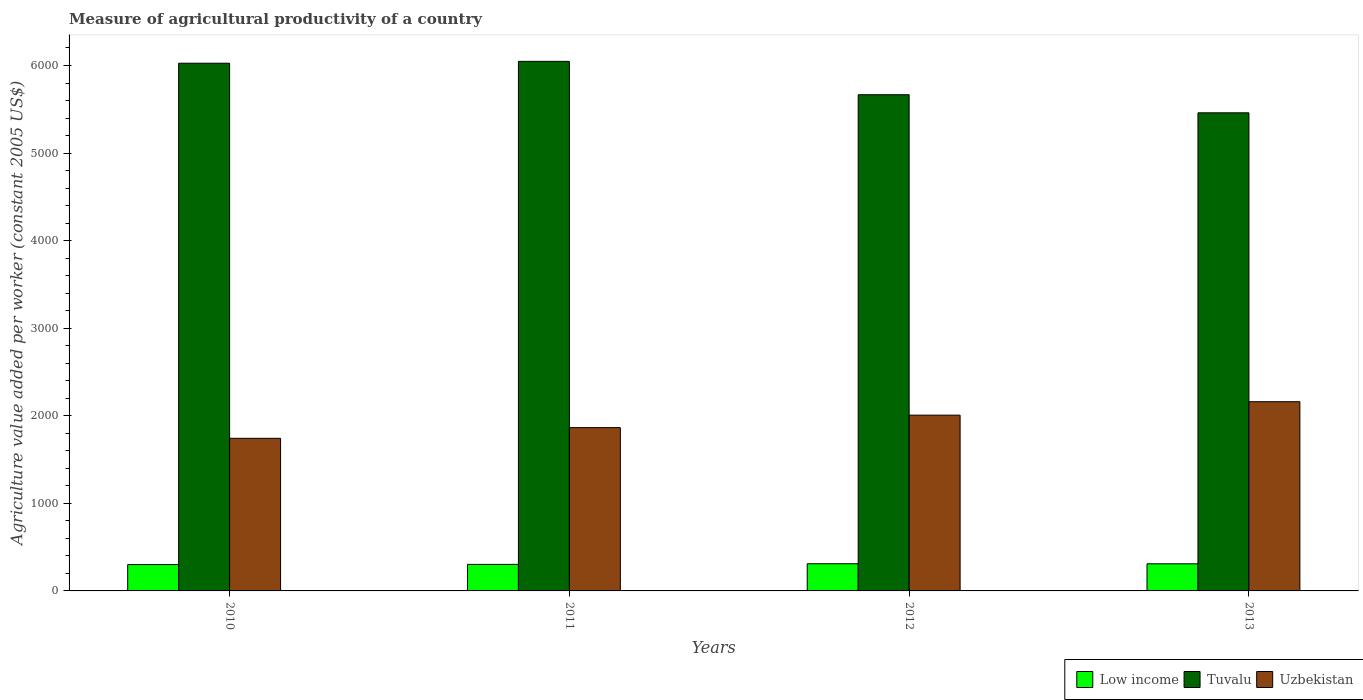How many different coloured bars are there?
Provide a short and direct response. 3. Are the number of bars per tick equal to the number of legend labels?
Provide a succinct answer. Yes. How many bars are there on the 3rd tick from the left?
Provide a short and direct response. 3. In how many cases, is the number of bars for a given year not equal to the number of legend labels?
Offer a very short reply. 0. What is the measure of agricultural productivity in Low income in 2012?
Offer a very short reply. 310.29. Across all years, what is the maximum measure of agricultural productivity in Tuvalu?
Provide a succinct answer. 6047.47. Across all years, what is the minimum measure of agricultural productivity in Uzbekistan?
Your answer should be compact. 1742.87. What is the total measure of agricultural productivity in Low income in the graph?
Give a very brief answer. 1223.9. What is the difference between the measure of agricultural productivity in Uzbekistan in 2011 and that in 2012?
Provide a short and direct response. -142.45. What is the difference between the measure of agricultural productivity in Tuvalu in 2011 and the measure of agricultural productivity in Low income in 2012?
Keep it short and to the point. 5737.18. What is the average measure of agricultural productivity in Low income per year?
Offer a very short reply. 305.97. In the year 2013, what is the difference between the measure of agricultural productivity in Uzbekistan and measure of agricultural productivity in Tuvalu?
Your answer should be very brief. -3299.08. In how many years, is the measure of agricultural productivity in Low income greater than 1600 US$?
Give a very brief answer. 0. What is the ratio of the measure of agricultural productivity in Uzbekistan in 2011 to that in 2012?
Your answer should be compact. 0.93. Is the difference between the measure of agricultural productivity in Uzbekistan in 2011 and 2012 greater than the difference between the measure of agricultural productivity in Tuvalu in 2011 and 2012?
Ensure brevity in your answer.  No. What is the difference between the highest and the second highest measure of agricultural productivity in Low income?
Keep it short and to the point. 0.69. What is the difference between the highest and the lowest measure of agricultural productivity in Tuvalu?
Your response must be concise. 587.72. Is the sum of the measure of agricultural productivity in Tuvalu in 2011 and 2013 greater than the maximum measure of agricultural productivity in Uzbekistan across all years?
Your response must be concise. Yes. What does the 2nd bar from the left in 2011 represents?
Ensure brevity in your answer.  Tuvalu. What does the 1st bar from the right in 2010 represents?
Your answer should be very brief. Uzbekistan. Is it the case that in every year, the sum of the measure of agricultural productivity in Tuvalu and measure of agricultural productivity in Uzbekistan is greater than the measure of agricultural productivity in Low income?
Make the answer very short. Yes. Are all the bars in the graph horizontal?
Your answer should be very brief. No. Are the values on the major ticks of Y-axis written in scientific E-notation?
Ensure brevity in your answer.  No. Where does the legend appear in the graph?
Keep it short and to the point. Bottom right. How many legend labels are there?
Keep it short and to the point. 3. How are the legend labels stacked?
Offer a terse response. Horizontal. What is the title of the graph?
Offer a terse response. Measure of agricultural productivity of a country. Does "Solomon Islands" appear as one of the legend labels in the graph?
Make the answer very short. No. What is the label or title of the X-axis?
Offer a very short reply. Years. What is the label or title of the Y-axis?
Your answer should be compact. Agriculture value added per worker (constant 2005 US$). What is the Agriculture value added per worker (constant 2005 US$) of Low income in 2010?
Provide a succinct answer. 300.88. What is the Agriculture value added per worker (constant 2005 US$) of Tuvalu in 2010?
Your answer should be compact. 6026.09. What is the Agriculture value added per worker (constant 2005 US$) in Uzbekistan in 2010?
Give a very brief answer. 1742.87. What is the Agriculture value added per worker (constant 2005 US$) in Low income in 2011?
Ensure brevity in your answer.  303.13. What is the Agriculture value added per worker (constant 2005 US$) of Tuvalu in 2011?
Provide a short and direct response. 6047.47. What is the Agriculture value added per worker (constant 2005 US$) in Uzbekistan in 2011?
Provide a succinct answer. 1864.79. What is the Agriculture value added per worker (constant 2005 US$) of Low income in 2012?
Your response must be concise. 310.29. What is the Agriculture value added per worker (constant 2005 US$) of Tuvalu in 2012?
Offer a very short reply. 5666.4. What is the Agriculture value added per worker (constant 2005 US$) in Uzbekistan in 2012?
Offer a very short reply. 2007.24. What is the Agriculture value added per worker (constant 2005 US$) in Low income in 2013?
Ensure brevity in your answer.  309.6. What is the Agriculture value added per worker (constant 2005 US$) of Tuvalu in 2013?
Provide a short and direct response. 5459.75. What is the Agriculture value added per worker (constant 2005 US$) of Uzbekistan in 2013?
Provide a short and direct response. 2160.67. Across all years, what is the maximum Agriculture value added per worker (constant 2005 US$) of Low income?
Your response must be concise. 310.29. Across all years, what is the maximum Agriculture value added per worker (constant 2005 US$) in Tuvalu?
Ensure brevity in your answer.  6047.47. Across all years, what is the maximum Agriculture value added per worker (constant 2005 US$) in Uzbekistan?
Provide a short and direct response. 2160.67. Across all years, what is the minimum Agriculture value added per worker (constant 2005 US$) in Low income?
Ensure brevity in your answer.  300.88. Across all years, what is the minimum Agriculture value added per worker (constant 2005 US$) of Tuvalu?
Ensure brevity in your answer.  5459.75. Across all years, what is the minimum Agriculture value added per worker (constant 2005 US$) in Uzbekistan?
Offer a terse response. 1742.87. What is the total Agriculture value added per worker (constant 2005 US$) in Low income in the graph?
Provide a short and direct response. 1223.9. What is the total Agriculture value added per worker (constant 2005 US$) in Tuvalu in the graph?
Make the answer very short. 2.32e+04. What is the total Agriculture value added per worker (constant 2005 US$) of Uzbekistan in the graph?
Offer a very short reply. 7775.57. What is the difference between the Agriculture value added per worker (constant 2005 US$) of Low income in 2010 and that in 2011?
Provide a succinct answer. -2.26. What is the difference between the Agriculture value added per worker (constant 2005 US$) of Tuvalu in 2010 and that in 2011?
Give a very brief answer. -21.38. What is the difference between the Agriculture value added per worker (constant 2005 US$) in Uzbekistan in 2010 and that in 2011?
Offer a terse response. -121.92. What is the difference between the Agriculture value added per worker (constant 2005 US$) of Low income in 2010 and that in 2012?
Keep it short and to the point. -9.41. What is the difference between the Agriculture value added per worker (constant 2005 US$) in Tuvalu in 2010 and that in 2012?
Your answer should be compact. 359.69. What is the difference between the Agriculture value added per worker (constant 2005 US$) of Uzbekistan in 2010 and that in 2012?
Your answer should be compact. -264.38. What is the difference between the Agriculture value added per worker (constant 2005 US$) in Low income in 2010 and that in 2013?
Offer a very short reply. -8.72. What is the difference between the Agriculture value added per worker (constant 2005 US$) of Tuvalu in 2010 and that in 2013?
Ensure brevity in your answer.  566.33. What is the difference between the Agriculture value added per worker (constant 2005 US$) in Uzbekistan in 2010 and that in 2013?
Offer a very short reply. -417.8. What is the difference between the Agriculture value added per worker (constant 2005 US$) of Low income in 2011 and that in 2012?
Keep it short and to the point. -7.16. What is the difference between the Agriculture value added per worker (constant 2005 US$) of Tuvalu in 2011 and that in 2012?
Keep it short and to the point. 381.07. What is the difference between the Agriculture value added per worker (constant 2005 US$) in Uzbekistan in 2011 and that in 2012?
Your response must be concise. -142.45. What is the difference between the Agriculture value added per worker (constant 2005 US$) of Low income in 2011 and that in 2013?
Your answer should be very brief. -6.46. What is the difference between the Agriculture value added per worker (constant 2005 US$) of Tuvalu in 2011 and that in 2013?
Keep it short and to the point. 587.72. What is the difference between the Agriculture value added per worker (constant 2005 US$) in Uzbekistan in 2011 and that in 2013?
Make the answer very short. -295.88. What is the difference between the Agriculture value added per worker (constant 2005 US$) of Low income in 2012 and that in 2013?
Make the answer very short. 0.69. What is the difference between the Agriculture value added per worker (constant 2005 US$) of Tuvalu in 2012 and that in 2013?
Make the answer very short. 206.65. What is the difference between the Agriculture value added per worker (constant 2005 US$) of Uzbekistan in 2012 and that in 2013?
Keep it short and to the point. -153.43. What is the difference between the Agriculture value added per worker (constant 2005 US$) in Low income in 2010 and the Agriculture value added per worker (constant 2005 US$) in Tuvalu in 2011?
Ensure brevity in your answer.  -5746.59. What is the difference between the Agriculture value added per worker (constant 2005 US$) in Low income in 2010 and the Agriculture value added per worker (constant 2005 US$) in Uzbekistan in 2011?
Your answer should be compact. -1563.91. What is the difference between the Agriculture value added per worker (constant 2005 US$) in Tuvalu in 2010 and the Agriculture value added per worker (constant 2005 US$) in Uzbekistan in 2011?
Ensure brevity in your answer.  4161.3. What is the difference between the Agriculture value added per worker (constant 2005 US$) in Low income in 2010 and the Agriculture value added per worker (constant 2005 US$) in Tuvalu in 2012?
Make the answer very short. -5365.52. What is the difference between the Agriculture value added per worker (constant 2005 US$) of Low income in 2010 and the Agriculture value added per worker (constant 2005 US$) of Uzbekistan in 2012?
Your answer should be compact. -1706.36. What is the difference between the Agriculture value added per worker (constant 2005 US$) in Tuvalu in 2010 and the Agriculture value added per worker (constant 2005 US$) in Uzbekistan in 2012?
Make the answer very short. 4018.85. What is the difference between the Agriculture value added per worker (constant 2005 US$) in Low income in 2010 and the Agriculture value added per worker (constant 2005 US$) in Tuvalu in 2013?
Your answer should be very brief. -5158.88. What is the difference between the Agriculture value added per worker (constant 2005 US$) in Low income in 2010 and the Agriculture value added per worker (constant 2005 US$) in Uzbekistan in 2013?
Keep it short and to the point. -1859.79. What is the difference between the Agriculture value added per worker (constant 2005 US$) of Tuvalu in 2010 and the Agriculture value added per worker (constant 2005 US$) of Uzbekistan in 2013?
Offer a very short reply. 3865.42. What is the difference between the Agriculture value added per worker (constant 2005 US$) of Low income in 2011 and the Agriculture value added per worker (constant 2005 US$) of Tuvalu in 2012?
Your response must be concise. -5363.27. What is the difference between the Agriculture value added per worker (constant 2005 US$) of Low income in 2011 and the Agriculture value added per worker (constant 2005 US$) of Uzbekistan in 2012?
Your answer should be compact. -1704.11. What is the difference between the Agriculture value added per worker (constant 2005 US$) in Tuvalu in 2011 and the Agriculture value added per worker (constant 2005 US$) in Uzbekistan in 2012?
Make the answer very short. 4040.23. What is the difference between the Agriculture value added per worker (constant 2005 US$) in Low income in 2011 and the Agriculture value added per worker (constant 2005 US$) in Tuvalu in 2013?
Make the answer very short. -5156.62. What is the difference between the Agriculture value added per worker (constant 2005 US$) in Low income in 2011 and the Agriculture value added per worker (constant 2005 US$) in Uzbekistan in 2013?
Your answer should be compact. -1857.54. What is the difference between the Agriculture value added per worker (constant 2005 US$) in Tuvalu in 2011 and the Agriculture value added per worker (constant 2005 US$) in Uzbekistan in 2013?
Offer a terse response. 3886.8. What is the difference between the Agriculture value added per worker (constant 2005 US$) of Low income in 2012 and the Agriculture value added per worker (constant 2005 US$) of Tuvalu in 2013?
Offer a very short reply. -5149.46. What is the difference between the Agriculture value added per worker (constant 2005 US$) in Low income in 2012 and the Agriculture value added per worker (constant 2005 US$) in Uzbekistan in 2013?
Your response must be concise. -1850.38. What is the difference between the Agriculture value added per worker (constant 2005 US$) in Tuvalu in 2012 and the Agriculture value added per worker (constant 2005 US$) in Uzbekistan in 2013?
Your response must be concise. 3505.73. What is the average Agriculture value added per worker (constant 2005 US$) in Low income per year?
Offer a very short reply. 305.97. What is the average Agriculture value added per worker (constant 2005 US$) of Tuvalu per year?
Make the answer very short. 5799.93. What is the average Agriculture value added per worker (constant 2005 US$) of Uzbekistan per year?
Keep it short and to the point. 1943.89. In the year 2010, what is the difference between the Agriculture value added per worker (constant 2005 US$) in Low income and Agriculture value added per worker (constant 2005 US$) in Tuvalu?
Ensure brevity in your answer.  -5725.21. In the year 2010, what is the difference between the Agriculture value added per worker (constant 2005 US$) in Low income and Agriculture value added per worker (constant 2005 US$) in Uzbekistan?
Give a very brief answer. -1441.99. In the year 2010, what is the difference between the Agriculture value added per worker (constant 2005 US$) in Tuvalu and Agriculture value added per worker (constant 2005 US$) in Uzbekistan?
Provide a succinct answer. 4283.22. In the year 2011, what is the difference between the Agriculture value added per worker (constant 2005 US$) in Low income and Agriculture value added per worker (constant 2005 US$) in Tuvalu?
Your answer should be very brief. -5744.34. In the year 2011, what is the difference between the Agriculture value added per worker (constant 2005 US$) of Low income and Agriculture value added per worker (constant 2005 US$) of Uzbekistan?
Offer a terse response. -1561.66. In the year 2011, what is the difference between the Agriculture value added per worker (constant 2005 US$) in Tuvalu and Agriculture value added per worker (constant 2005 US$) in Uzbekistan?
Your response must be concise. 4182.68. In the year 2012, what is the difference between the Agriculture value added per worker (constant 2005 US$) of Low income and Agriculture value added per worker (constant 2005 US$) of Tuvalu?
Provide a succinct answer. -5356.11. In the year 2012, what is the difference between the Agriculture value added per worker (constant 2005 US$) in Low income and Agriculture value added per worker (constant 2005 US$) in Uzbekistan?
Your answer should be compact. -1696.95. In the year 2012, what is the difference between the Agriculture value added per worker (constant 2005 US$) of Tuvalu and Agriculture value added per worker (constant 2005 US$) of Uzbekistan?
Give a very brief answer. 3659.16. In the year 2013, what is the difference between the Agriculture value added per worker (constant 2005 US$) in Low income and Agriculture value added per worker (constant 2005 US$) in Tuvalu?
Make the answer very short. -5150.15. In the year 2013, what is the difference between the Agriculture value added per worker (constant 2005 US$) of Low income and Agriculture value added per worker (constant 2005 US$) of Uzbekistan?
Give a very brief answer. -1851.07. In the year 2013, what is the difference between the Agriculture value added per worker (constant 2005 US$) of Tuvalu and Agriculture value added per worker (constant 2005 US$) of Uzbekistan?
Ensure brevity in your answer.  3299.08. What is the ratio of the Agriculture value added per worker (constant 2005 US$) in Uzbekistan in 2010 to that in 2011?
Provide a short and direct response. 0.93. What is the ratio of the Agriculture value added per worker (constant 2005 US$) of Low income in 2010 to that in 2012?
Keep it short and to the point. 0.97. What is the ratio of the Agriculture value added per worker (constant 2005 US$) in Tuvalu in 2010 to that in 2012?
Offer a terse response. 1.06. What is the ratio of the Agriculture value added per worker (constant 2005 US$) in Uzbekistan in 2010 to that in 2012?
Your response must be concise. 0.87. What is the ratio of the Agriculture value added per worker (constant 2005 US$) in Low income in 2010 to that in 2013?
Your answer should be very brief. 0.97. What is the ratio of the Agriculture value added per worker (constant 2005 US$) of Tuvalu in 2010 to that in 2013?
Offer a terse response. 1.1. What is the ratio of the Agriculture value added per worker (constant 2005 US$) of Uzbekistan in 2010 to that in 2013?
Make the answer very short. 0.81. What is the ratio of the Agriculture value added per worker (constant 2005 US$) of Low income in 2011 to that in 2012?
Your answer should be compact. 0.98. What is the ratio of the Agriculture value added per worker (constant 2005 US$) in Tuvalu in 2011 to that in 2012?
Offer a very short reply. 1.07. What is the ratio of the Agriculture value added per worker (constant 2005 US$) of Uzbekistan in 2011 to that in 2012?
Your answer should be compact. 0.93. What is the ratio of the Agriculture value added per worker (constant 2005 US$) of Low income in 2011 to that in 2013?
Provide a succinct answer. 0.98. What is the ratio of the Agriculture value added per worker (constant 2005 US$) of Tuvalu in 2011 to that in 2013?
Ensure brevity in your answer.  1.11. What is the ratio of the Agriculture value added per worker (constant 2005 US$) in Uzbekistan in 2011 to that in 2013?
Your answer should be compact. 0.86. What is the ratio of the Agriculture value added per worker (constant 2005 US$) in Low income in 2012 to that in 2013?
Make the answer very short. 1. What is the ratio of the Agriculture value added per worker (constant 2005 US$) in Tuvalu in 2012 to that in 2013?
Offer a very short reply. 1.04. What is the ratio of the Agriculture value added per worker (constant 2005 US$) of Uzbekistan in 2012 to that in 2013?
Offer a terse response. 0.93. What is the difference between the highest and the second highest Agriculture value added per worker (constant 2005 US$) of Low income?
Your response must be concise. 0.69. What is the difference between the highest and the second highest Agriculture value added per worker (constant 2005 US$) of Tuvalu?
Offer a terse response. 21.38. What is the difference between the highest and the second highest Agriculture value added per worker (constant 2005 US$) in Uzbekistan?
Your response must be concise. 153.43. What is the difference between the highest and the lowest Agriculture value added per worker (constant 2005 US$) of Low income?
Provide a short and direct response. 9.41. What is the difference between the highest and the lowest Agriculture value added per worker (constant 2005 US$) in Tuvalu?
Keep it short and to the point. 587.72. What is the difference between the highest and the lowest Agriculture value added per worker (constant 2005 US$) of Uzbekistan?
Give a very brief answer. 417.8. 